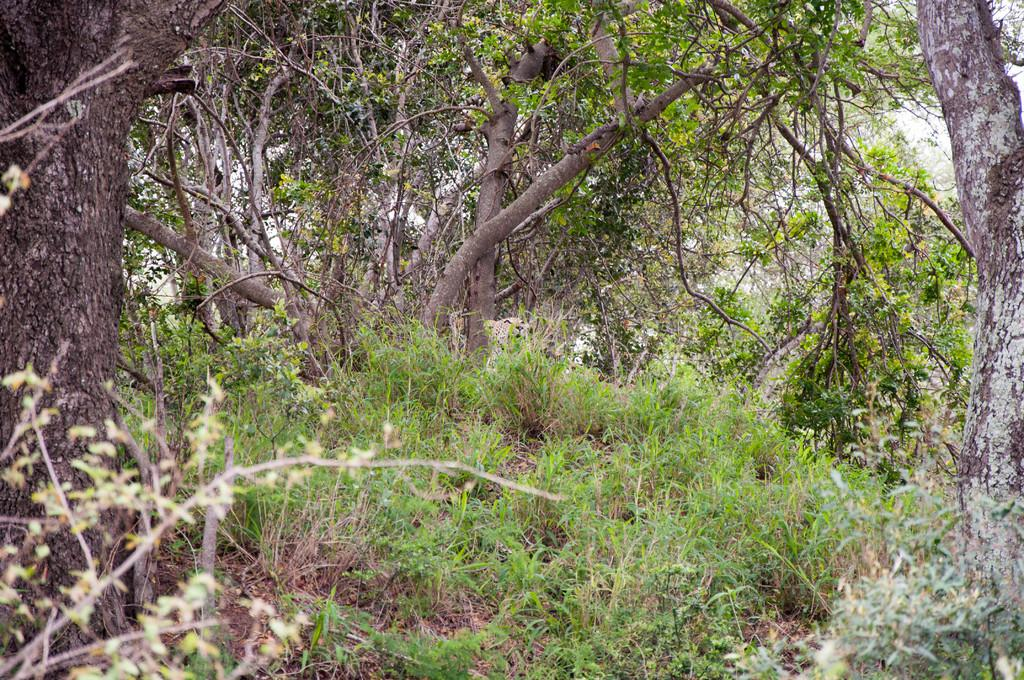What type of vegetation can be seen in the image? There are trees in the image. What else can be seen on the ground in the image? There is grass in the image. Where is the hook located in the image? There is no hook present in the image. What type of bat can be seen flying in the image? There is no bat present in the image. 